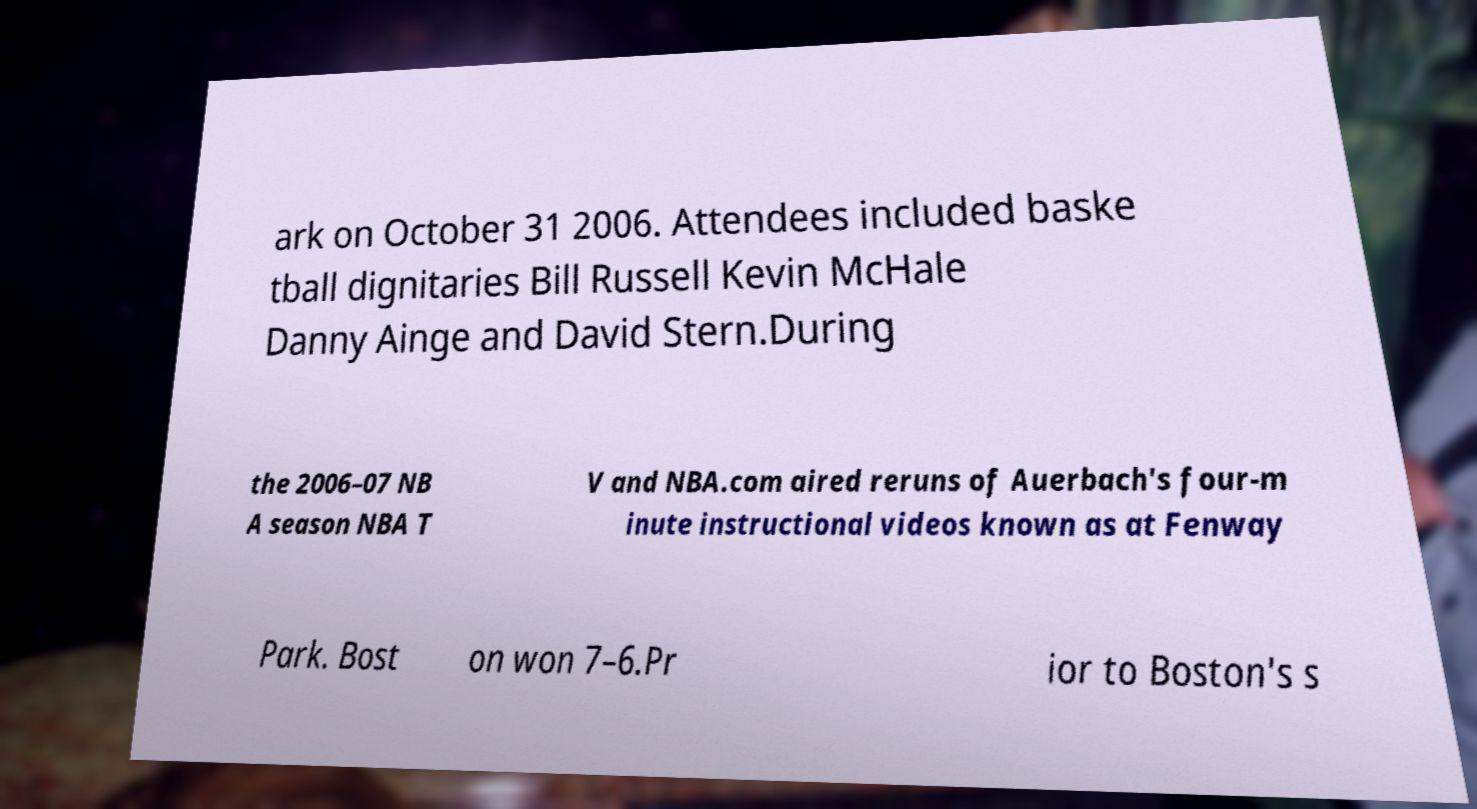What messages or text are displayed in this image? I need them in a readable, typed format. ark on October 31 2006. Attendees included baske tball dignitaries Bill Russell Kevin McHale Danny Ainge and David Stern.During the 2006–07 NB A season NBA T V and NBA.com aired reruns of Auerbach's four-m inute instructional videos known as at Fenway Park. Bost on won 7–6.Pr ior to Boston's s 